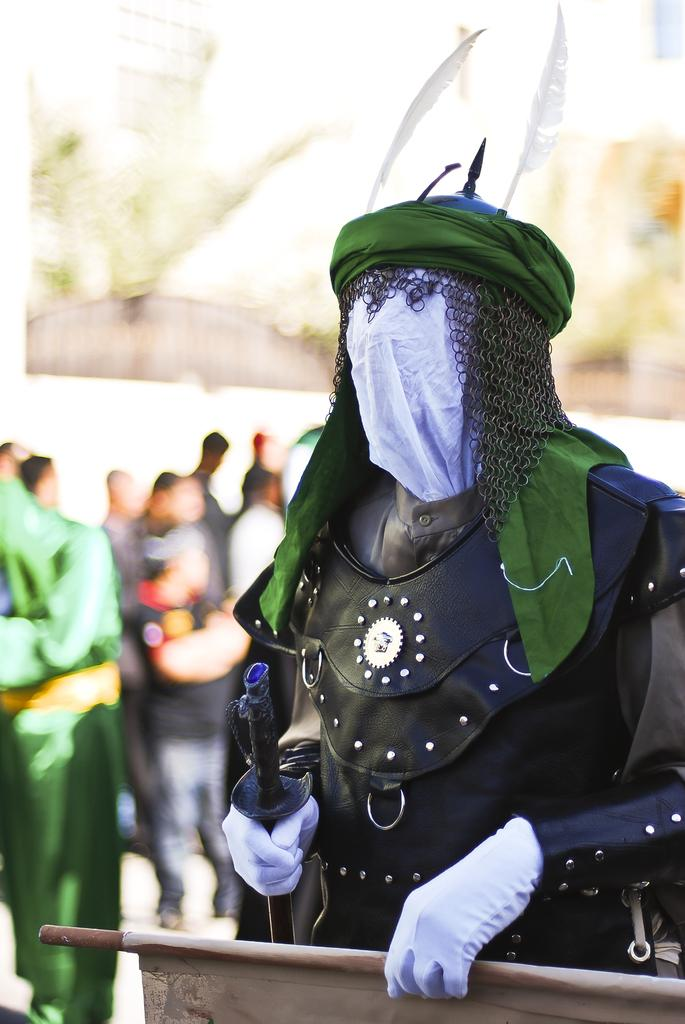What is happening in the image? There are people standing in the image. Can you describe the appearance of one of the individuals? A man is wearing a mask. What is the man holding in his hand? The man is holding a banner in his hand. What type of stitch is being used to sew the man's mask in the image? There is no indication in the image that the man's mask is being sewn or that any stitch is being used. 